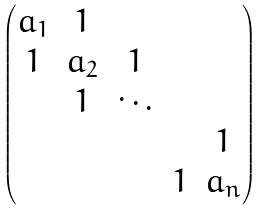Convert formula to latex. <formula><loc_0><loc_0><loc_500><loc_500>\begin{pmatrix} a _ { 1 } & 1 & & & \\ 1 & a _ { 2 } & 1 & & \\ & 1 & \ddots & & \\ & & & & 1 \\ & & & 1 & a _ { n } \end{pmatrix}</formula> 